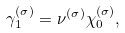<formula> <loc_0><loc_0><loc_500><loc_500>\gamma _ { 1 } ^ { ( \sigma ) } = \nu ^ { ( \sigma ) } \chi ^ { ( \sigma ) } _ { 0 } ,</formula> 